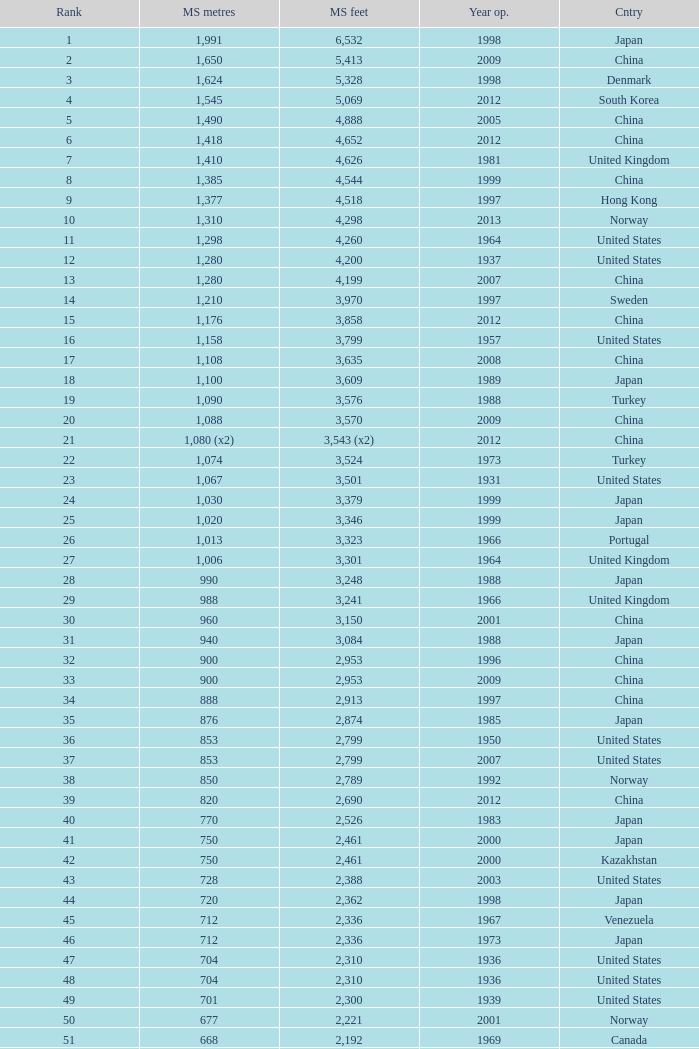What is the highest rank from the year greater than 2010 with 430 main span metres? 94.0. 